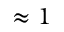<formula> <loc_0><loc_0><loc_500><loc_500>\approx 1</formula> 